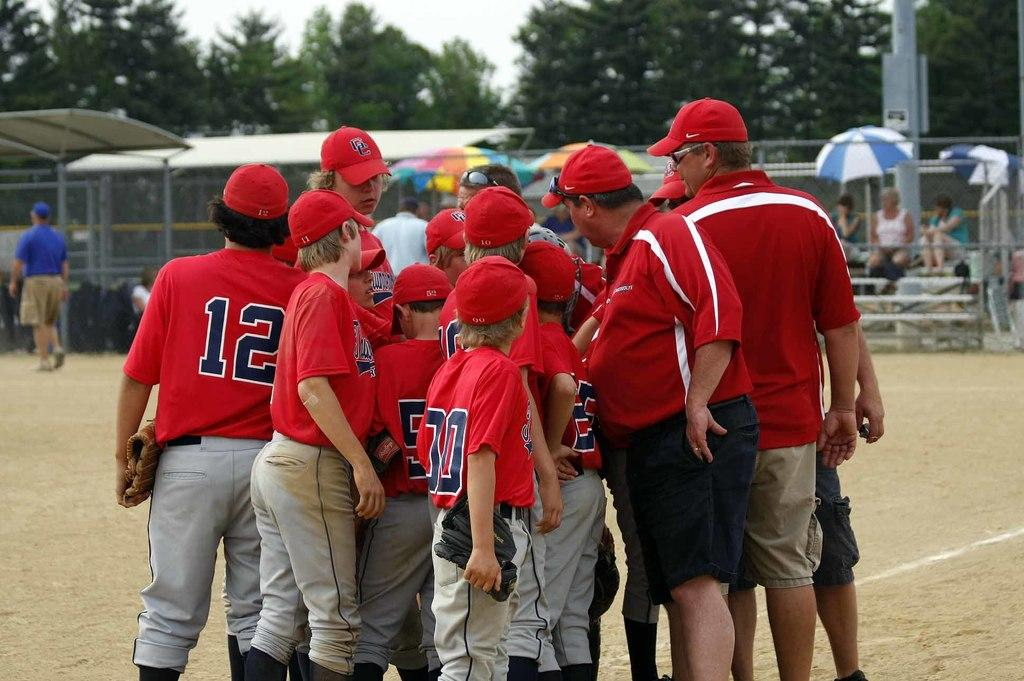<image>
Give a short and clear explanation of the subsequent image. A group of players the one on the left with 12 on his back. 